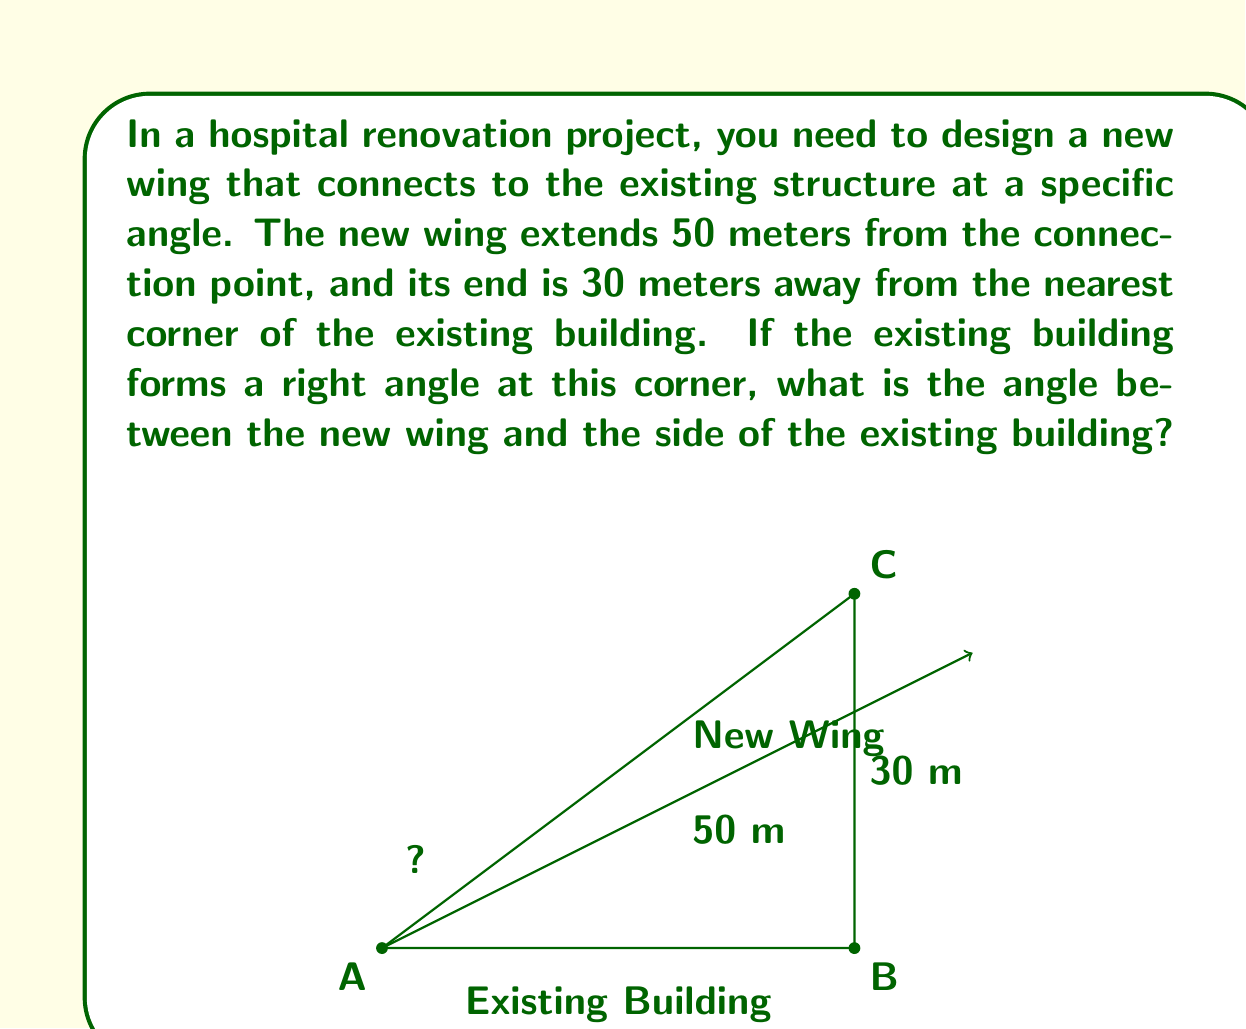Give your solution to this math problem. Let's approach this step-by-step using trigonometry:

1) First, we need to identify the triangle formed by the new wing, the side of the existing building, and the line connecting the end of the new wing to the corner of the existing building.

2) In this triangle, we know:
   - The hypotenuse (the new wing): 50 meters
   - The opposite side (distance from the end of the new wing to the existing building): 30 meters

3) We can use the arcsine function to find the angle. Let's call the angle we're looking for $\theta$.

4) In a right-angled triangle, $\sin(\theta) = \frac{\text{opposite}}{\text{hypotenuse}}$

5) Plugging in our values:

   $$\sin(\theta) = \frac{30}{50}$$

6) To find $\theta$, we need to take the inverse sine (arcsine) of both sides:

   $$\theta = \arcsin(\frac{30}{50})$$

7) Using a calculator or computer:

   $$\theta \approx 36.87°$$

8) However, this is not our final answer. This angle is between the new wing and the perpendicular to the existing building. We need to subtract this from 90° to get the angle between the new wing and the existing building.

9) Final calculation:

   $$90° - 36.87° = 53.13°$$

Therefore, the angle between the new wing and the side of the existing building is approximately 53.13°.
Answer: The angle between the new wing and the side of the existing building is approximately $53.13°$. 